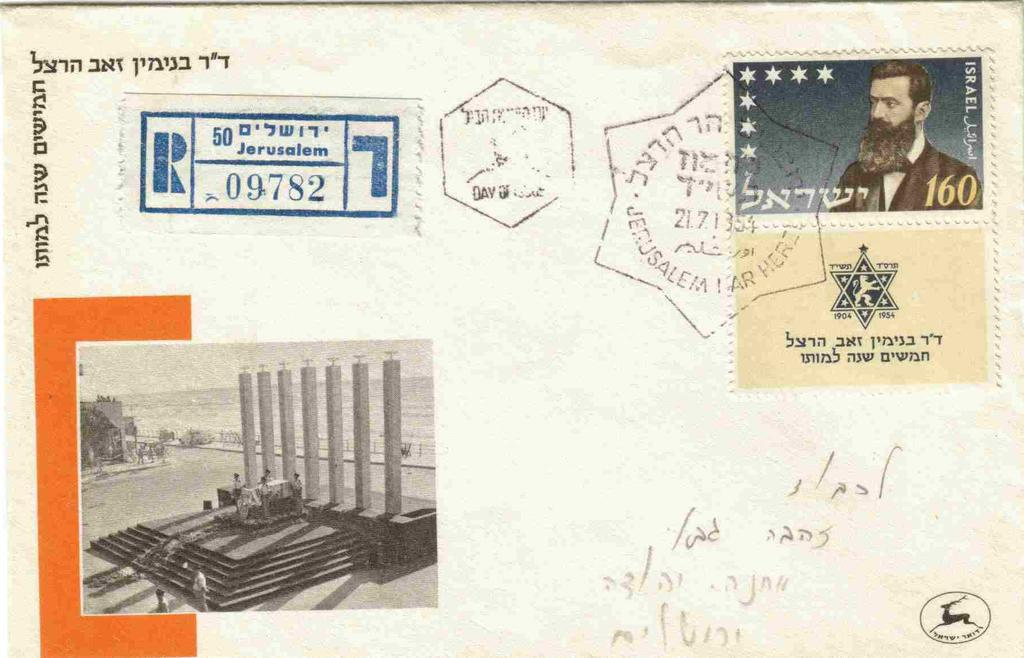<image>
Provide a brief description of the given image. an envelope that says 'jerusalem' in blue on it 